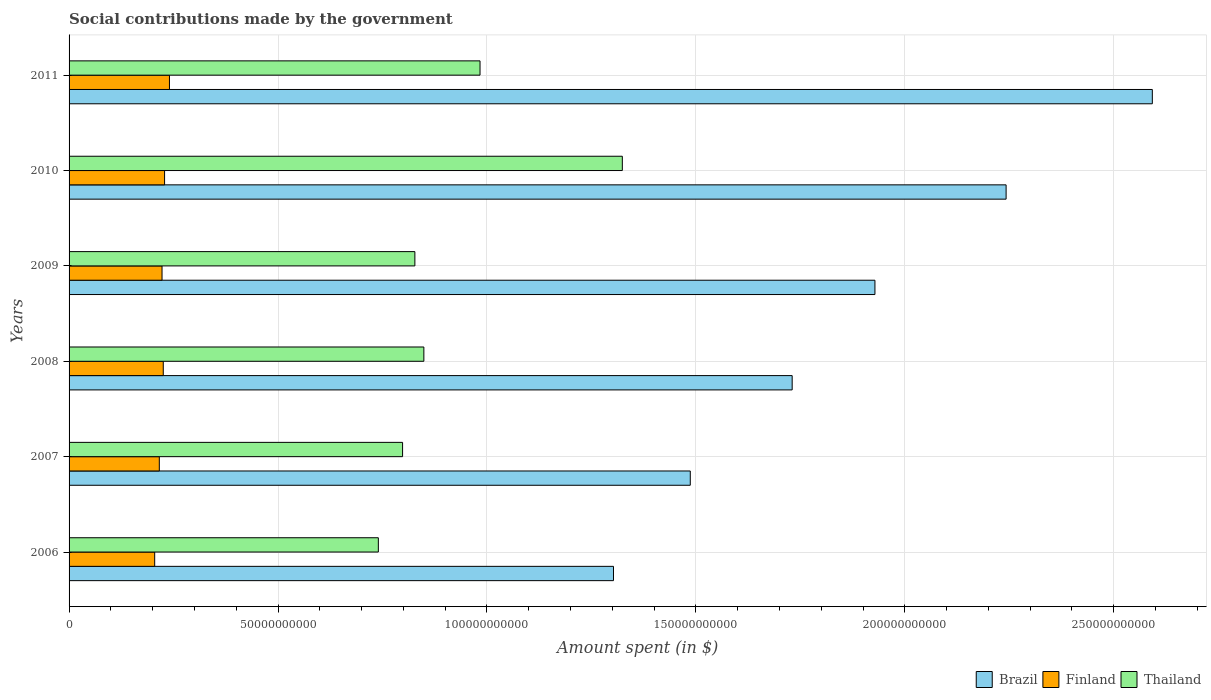How many different coloured bars are there?
Keep it short and to the point. 3. How many groups of bars are there?
Offer a very short reply. 6. Are the number of bars on each tick of the Y-axis equal?
Make the answer very short. Yes. How many bars are there on the 5th tick from the top?
Provide a short and direct response. 3. How many bars are there on the 3rd tick from the bottom?
Offer a very short reply. 3. What is the label of the 3rd group of bars from the top?
Your response must be concise. 2009. In how many cases, is the number of bars for a given year not equal to the number of legend labels?
Give a very brief answer. 0. What is the amount spent on social contributions in Finland in 2010?
Give a very brief answer. 2.29e+1. Across all years, what is the maximum amount spent on social contributions in Brazil?
Keep it short and to the point. 2.59e+11. Across all years, what is the minimum amount spent on social contributions in Brazil?
Your answer should be very brief. 1.30e+11. In which year was the amount spent on social contributions in Brazil minimum?
Your response must be concise. 2006. What is the total amount spent on social contributions in Brazil in the graph?
Give a very brief answer. 1.13e+12. What is the difference between the amount spent on social contributions in Thailand in 2008 and that in 2010?
Ensure brevity in your answer.  -4.75e+1. What is the difference between the amount spent on social contributions in Brazil in 2006 and the amount spent on social contributions in Finland in 2011?
Your answer should be compact. 1.06e+11. What is the average amount spent on social contributions in Brazil per year?
Offer a terse response. 1.88e+11. In the year 2011, what is the difference between the amount spent on social contributions in Finland and amount spent on social contributions in Brazil?
Your answer should be very brief. -2.35e+11. In how many years, is the amount spent on social contributions in Brazil greater than 40000000000 $?
Offer a terse response. 6. What is the ratio of the amount spent on social contributions in Finland in 2008 to that in 2011?
Provide a succinct answer. 0.94. Is the difference between the amount spent on social contributions in Finland in 2006 and 2007 greater than the difference between the amount spent on social contributions in Brazil in 2006 and 2007?
Make the answer very short. Yes. What is the difference between the highest and the second highest amount spent on social contributions in Thailand?
Ensure brevity in your answer.  3.41e+1. What is the difference between the highest and the lowest amount spent on social contributions in Brazil?
Ensure brevity in your answer.  1.29e+11. What does the 1st bar from the top in 2009 represents?
Offer a very short reply. Thailand. What does the 3rd bar from the bottom in 2006 represents?
Offer a terse response. Thailand. Is it the case that in every year, the sum of the amount spent on social contributions in Thailand and amount spent on social contributions in Finland is greater than the amount spent on social contributions in Brazil?
Offer a terse response. No. How many bars are there?
Your answer should be very brief. 18. Are all the bars in the graph horizontal?
Your answer should be compact. Yes. Where does the legend appear in the graph?
Give a very brief answer. Bottom right. How many legend labels are there?
Give a very brief answer. 3. How are the legend labels stacked?
Offer a very short reply. Horizontal. What is the title of the graph?
Provide a succinct answer. Social contributions made by the government. Does "Tanzania" appear as one of the legend labels in the graph?
Your answer should be compact. No. What is the label or title of the X-axis?
Keep it short and to the point. Amount spent (in $). What is the Amount spent (in $) of Brazil in 2006?
Your response must be concise. 1.30e+11. What is the Amount spent (in $) of Finland in 2006?
Provide a short and direct response. 2.05e+1. What is the Amount spent (in $) of Thailand in 2006?
Your response must be concise. 7.40e+1. What is the Amount spent (in $) in Brazil in 2007?
Provide a succinct answer. 1.49e+11. What is the Amount spent (in $) of Finland in 2007?
Offer a terse response. 2.16e+1. What is the Amount spent (in $) in Thailand in 2007?
Offer a terse response. 7.98e+1. What is the Amount spent (in $) in Brazil in 2008?
Make the answer very short. 1.73e+11. What is the Amount spent (in $) of Finland in 2008?
Offer a very short reply. 2.25e+1. What is the Amount spent (in $) of Thailand in 2008?
Provide a succinct answer. 8.49e+1. What is the Amount spent (in $) in Brazil in 2009?
Offer a very short reply. 1.93e+11. What is the Amount spent (in $) of Finland in 2009?
Your response must be concise. 2.22e+1. What is the Amount spent (in $) in Thailand in 2009?
Your answer should be compact. 8.28e+1. What is the Amount spent (in $) of Brazil in 2010?
Provide a short and direct response. 2.24e+11. What is the Amount spent (in $) of Finland in 2010?
Make the answer very short. 2.29e+1. What is the Amount spent (in $) of Thailand in 2010?
Keep it short and to the point. 1.32e+11. What is the Amount spent (in $) of Brazil in 2011?
Ensure brevity in your answer.  2.59e+11. What is the Amount spent (in $) in Finland in 2011?
Your response must be concise. 2.40e+1. What is the Amount spent (in $) in Thailand in 2011?
Ensure brevity in your answer.  9.83e+1. Across all years, what is the maximum Amount spent (in $) of Brazil?
Provide a succinct answer. 2.59e+11. Across all years, what is the maximum Amount spent (in $) of Finland?
Offer a very short reply. 2.40e+1. Across all years, what is the maximum Amount spent (in $) in Thailand?
Keep it short and to the point. 1.32e+11. Across all years, what is the minimum Amount spent (in $) in Brazil?
Offer a very short reply. 1.30e+11. Across all years, what is the minimum Amount spent (in $) of Finland?
Make the answer very short. 2.05e+1. Across all years, what is the minimum Amount spent (in $) of Thailand?
Your response must be concise. 7.40e+1. What is the total Amount spent (in $) in Brazil in the graph?
Keep it short and to the point. 1.13e+12. What is the total Amount spent (in $) of Finland in the graph?
Provide a short and direct response. 1.34e+11. What is the total Amount spent (in $) of Thailand in the graph?
Keep it short and to the point. 5.52e+11. What is the difference between the Amount spent (in $) in Brazil in 2006 and that in 2007?
Offer a very short reply. -1.84e+1. What is the difference between the Amount spent (in $) in Finland in 2006 and that in 2007?
Provide a succinct answer. -1.11e+09. What is the difference between the Amount spent (in $) of Thailand in 2006 and that in 2007?
Make the answer very short. -5.80e+09. What is the difference between the Amount spent (in $) in Brazil in 2006 and that in 2008?
Provide a succinct answer. -4.28e+1. What is the difference between the Amount spent (in $) in Finland in 2006 and that in 2008?
Keep it short and to the point. -2.05e+09. What is the difference between the Amount spent (in $) in Thailand in 2006 and that in 2008?
Offer a terse response. -1.09e+1. What is the difference between the Amount spent (in $) in Brazil in 2006 and that in 2009?
Offer a terse response. -6.26e+1. What is the difference between the Amount spent (in $) in Finland in 2006 and that in 2009?
Your response must be concise. -1.76e+09. What is the difference between the Amount spent (in $) in Thailand in 2006 and that in 2009?
Ensure brevity in your answer.  -8.74e+09. What is the difference between the Amount spent (in $) in Brazil in 2006 and that in 2010?
Keep it short and to the point. -9.40e+1. What is the difference between the Amount spent (in $) of Finland in 2006 and that in 2010?
Your answer should be very brief. -2.37e+09. What is the difference between the Amount spent (in $) of Thailand in 2006 and that in 2010?
Your response must be concise. -5.84e+1. What is the difference between the Amount spent (in $) of Brazil in 2006 and that in 2011?
Make the answer very short. -1.29e+11. What is the difference between the Amount spent (in $) of Finland in 2006 and that in 2011?
Offer a very short reply. -3.54e+09. What is the difference between the Amount spent (in $) in Thailand in 2006 and that in 2011?
Offer a terse response. -2.43e+1. What is the difference between the Amount spent (in $) in Brazil in 2007 and that in 2008?
Ensure brevity in your answer.  -2.44e+1. What is the difference between the Amount spent (in $) in Finland in 2007 and that in 2008?
Give a very brief answer. -9.45e+08. What is the difference between the Amount spent (in $) in Thailand in 2007 and that in 2008?
Ensure brevity in your answer.  -5.09e+09. What is the difference between the Amount spent (in $) of Brazil in 2007 and that in 2009?
Give a very brief answer. -4.42e+1. What is the difference between the Amount spent (in $) of Finland in 2007 and that in 2009?
Your answer should be compact. -6.51e+08. What is the difference between the Amount spent (in $) in Thailand in 2007 and that in 2009?
Make the answer very short. -2.94e+09. What is the difference between the Amount spent (in $) of Brazil in 2007 and that in 2010?
Give a very brief answer. -7.56e+1. What is the difference between the Amount spent (in $) in Finland in 2007 and that in 2010?
Provide a short and direct response. -1.26e+09. What is the difference between the Amount spent (in $) of Thailand in 2007 and that in 2010?
Provide a short and direct response. -5.26e+1. What is the difference between the Amount spent (in $) in Brazil in 2007 and that in 2011?
Your answer should be very brief. -1.11e+11. What is the difference between the Amount spent (in $) in Finland in 2007 and that in 2011?
Your response must be concise. -2.43e+09. What is the difference between the Amount spent (in $) of Thailand in 2007 and that in 2011?
Give a very brief answer. -1.85e+1. What is the difference between the Amount spent (in $) in Brazil in 2008 and that in 2009?
Keep it short and to the point. -1.98e+1. What is the difference between the Amount spent (in $) in Finland in 2008 and that in 2009?
Provide a short and direct response. 2.94e+08. What is the difference between the Amount spent (in $) in Thailand in 2008 and that in 2009?
Provide a short and direct response. 2.15e+09. What is the difference between the Amount spent (in $) of Brazil in 2008 and that in 2010?
Your response must be concise. -5.12e+1. What is the difference between the Amount spent (in $) of Finland in 2008 and that in 2010?
Your response must be concise. -3.15e+08. What is the difference between the Amount spent (in $) of Thailand in 2008 and that in 2010?
Ensure brevity in your answer.  -4.75e+1. What is the difference between the Amount spent (in $) of Brazil in 2008 and that in 2011?
Offer a very short reply. -8.62e+1. What is the difference between the Amount spent (in $) in Finland in 2008 and that in 2011?
Your answer should be very brief. -1.48e+09. What is the difference between the Amount spent (in $) of Thailand in 2008 and that in 2011?
Your answer should be very brief. -1.34e+1. What is the difference between the Amount spent (in $) in Brazil in 2009 and that in 2010?
Provide a short and direct response. -3.14e+1. What is the difference between the Amount spent (in $) of Finland in 2009 and that in 2010?
Provide a short and direct response. -6.09e+08. What is the difference between the Amount spent (in $) of Thailand in 2009 and that in 2010?
Give a very brief answer. -4.96e+1. What is the difference between the Amount spent (in $) in Brazil in 2009 and that in 2011?
Provide a short and direct response. -6.64e+1. What is the difference between the Amount spent (in $) of Finland in 2009 and that in 2011?
Offer a very short reply. -1.78e+09. What is the difference between the Amount spent (in $) of Thailand in 2009 and that in 2011?
Your answer should be compact. -1.56e+1. What is the difference between the Amount spent (in $) in Brazil in 2010 and that in 2011?
Offer a terse response. -3.50e+1. What is the difference between the Amount spent (in $) of Finland in 2010 and that in 2011?
Your response must be concise. -1.17e+09. What is the difference between the Amount spent (in $) of Thailand in 2010 and that in 2011?
Your answer should be very brief. 3.41e+1. What is the difference between the Amount spent (in $) of Brazil in 2006 and the Amount spent (in $) of Finland in 2007?
Your answer should be very brief. 1.09e+11. What is the difference between the Amount spent (in $) of Brazil in 2006 and the Amount spent (in $) of Thailand in 2007?
Make the answer very short. 5.05e+1. What is the difference between the Amount spent (in $) of Finland in 2006 and the Amount spent (in $) of Thailand in 2007?
Give a very brief answer. -5.93e+1. What is the difference between the Amount spent (in $) of Brazil in 2006 and the Amount spent (in $) of Finland in 2008?
Ensure brevity in your answer.  1.08e+11. What is the difference between the Amount spent (in $) in Brazil in 2006 and the Amount spent (in $) in Thailand in 2008?
Make the answer very short. 4.54e+1. What is the difference between the Amount spent (in $) in Finland in 2006 and the Amount spent (in $) in Thailand in 2008?
Your answer should be very brief. -6.44e+1. What is the difference between the Amount spent (in $) in Brazil in 2006 and the Amount spent (in $) in Finland in 2009?
Provide a short and direct response. 1.08e+11. What is the difference between the Amount spent (in $) of Brazil in 2006 and the Amount spent (in $) of Thailand in 2009?
Ensure brevity in your answer.  4.75e+1. What is the difference between the Amount spent (in $) in Finland in 2006 and the Amount spent (in $) in Thailand in 2009?
Provide a short and direct response. -6.23e+1. What is the difference between the Amount spent (in $) of Brazil in 2006 and the Amount spent (in $) of Finland in 2010?
Give a very brief answer. 1.07e+11. What is the difference between the Amount spent (in $) in Brazil in 2006 and the Amount spent (in $) in Thailand in 2010?
Make the answer very short. -2.12e+09. What is the difference between the Amount spent (in $) in Finland in 2006 and the Amount spent (in $) in Thailand in 2010?
Your answer should be very brief. -1.12e+11. What is the difference between the Amount spent (in $) of Brazil in 2006 and the Amount spent (in $) of Finland in 2011?
Your answer should be very brief. 1.06e+11. What is the difference between the Amount spent (in $) of Brazil in 2006 and the Amount spent (in $) of Thailand in 2011?
Your answer should be compact. 3.19e+1. What is the difference between the Amount spent (in $) in Finland in 2006 and the Amount spent (in $) in Thailand in 2011?
Give a very brief answer. -7.79e+1. What is the difference between the Amount spent (in $) of Brazil in 2007 and the Amount spent (in $) of Finland in 2008?
Offer a very short reply. 1.26e+11. What is the difference between the Amount spent (in $) of Brazil in 2007 and the Amount spent (in $) of Thailand in 2008?
Your response must be concise. 6.38e+1. What is the difference between the Amount spent (in $) of Finland in 2007 and the Amount spent (in $) of Thailand in 2008?
Your answer should be very brief. -6.33e+1. What is the difference between the Amount spent (in $) in Brazil in 2007 and the Amount spent (in $) in Finland in 2009?
Provide a short and direct response. 1.26e+11. What is the difference between the Amount spent (in $) of Brazil in 2007 and the Amount spent (in $) of Thailand in 2009?
Your answer should be very brief. 6.59e+1. What is the difference between the Amount spent (in $) of Finland in 2007 and the Amount spent (in $) of Thailand in 2009?
Your answer should be compact. -6.12e+1. What is the difference between the Amount spent (in $) in Brazil in 2007 and the Amount spent (in $) in Finland in 2010?
Offer a terse response. 1.26e+11. What is the difference between the Amount spent (in $) of Brazil in 2007 and the Amount spent (in $) of Thailand in 2010?
Your answer should be compact. 1.63e+1. What is the difference between the Amount spent (in $) of Finland in 2007 and the Amount spent (in $) of Thailand in 2010?
Provide a succinct answer. -1.11e+11. What is the difference between the Amount spent (in $) in Brazil in 2007 and the Amount spent (in $) in Finland in 2011?
Make the answer very short. 1.25e+11. What is the difference between the Amount spent (in $) of Brazil in 2007 and the Amount spent (in $) of Thailand in 2011?
Give a very brief answer. 5.03e+1. What is the difference between the Amount spent (in $) of Finland in 2007 and the Amount spent (in $) of Thailand in 2011?
Offer a terse response. -7.67e+1. What is the difference between the Amount spent (in $) of Brazil in 2008 and the Amount spent (in $) of Finland in 2009?
Your answer should be compact. 1.51e+11. What is the difference between the Amount spent (in $) of Brazil in 2008 and the Amount spent (in $) of Thailand in 2009?
Provide a short and direct response. 9.03e+1. What is the difference between the Amount spent (in $) of Finland in 2008 and the Amount spent (in $) of Thailand in 2009?
Ensure brevity in your answer.  -6.02e+1. What is the difference between the Amount spent (in $) of Brazil in 2008 and the Amount spent (in $) of Finland in 2010?
Offer a terse response. 1.50e+11. What is the difference between the Amount spent (in $) of Brazil in 2008 and the Amount spent (in $) of Thailand in 2010?
Offer a terse response. 4.06e+1. What is the difference between the Amount spent (in $) of Finland in 2008 and the Amount spent (in $) of Thailand in 2010?
Make the answer very short. -1.10e+11. What is the difference between the Amount spent (in $) of Brazil in 2008 and the Amount spent (in $) of Finland in 2011?
Provide a succinct answer. 1.49e+11. What is the difference between the Amount spent (in $) of Brazil in 2008 and the Amount spent (in $) of Thailand in 2011?
Offer a terse response. 7.47e+1. What is the difference between the Amount spent (in $) of Finland in 2008 and the Amount spent (in $) of Thailand in 2011?
Your response must be concise. -7.58e+1. What is the difference between the Amount spent (in $) in Brazil in 2009 and the Amount spent (in $) in Finland in 2010?
Your response must be concise. 1.70e+11. What is the difference between the Amount spent (in $) of Brazil in 2009 and the Amount spent (in $) of Thailand in 2010?
Your answer should be compact. 6.05e+1. What is the difference between the Amount spent (in $) of Finland in 2009 and the Amount spent (in $) of Thailand in 2010?
Your answer should be compact. -1.10e+11. What is the difference between the Amount spent (in $) in Brazil in 2009 and the Amount spent (in $) in Finland in 2011?
Your response must be concise. 1.69e+11. What is the difference between the Amount spent (in $) in Brazil in 2009 and the Amount spent (in $) in Thailand in 2011?
Offer a very short reply. 9.45e+1. What is the difference between the Amount spent (in $) in Finland in 2009 and the Amount spent (in $) in Thailand in 2011?
Offer a terse response. -7.61e+1. What is the difference between the Amount spent (in $) of Brazil in 2010 and the Amount spent (in $) of Finland in 2011?
Offer a very short reply. 2.00e+11. What is the difference between the Amount spent (in $) of Brazil in 2010 and the Amount spent (in $) of Thailand in 2011?
Give a very brief answer. 1.26e+11. What is the difference between the Amount spent (in $) in Finland in 2010 and the Amount spent (in $) in Thailand in 2011?
Your answer should be compact. -7.55e+1. What is the average Amount spent (in $) of Brazil per year?
Provide a short and direct response. 1.88e+11. What is the average Amount spent (in $) in Finland per year?
Keep it short and to the point. 2.23e+1. What is the average Amount spent (in $) of Thailand per year?
Your answer should be compact. 9.20e+1. In the year 2006, what is the difference between the Amount spent (in $) of Brazil and Amount spent (in $) of Finland?
Your response must be concise. 1.10e+11. In the year 2006, what is the difference between the Amount spent (in $) in Brazil and Amount spent (in $) in Thailand?
Provide a short and direct response. 5.63e+1. In the year 2006, what is the difference between the Amount spent (in $) in Finland and Amount spent (in $) in Thailand?
Provide a short and direct response. -5.35e+1. In the year 2007, what is the difference between the Amount spent (in $) in Brazil and Amount spent (in $) in Finland?
Give a very brief answer. 1.27e+11. In the year 2007, what is the difference between the Amount spent (in $) in Brazil and Amount spent (in $) in Thailand?
Make the answer very short. 6.88e+1. In the year 2007, what is the difference between the Amount spent (in $) in Finland and Amount spent (in $) in Thailand?
Your answer should be very brief. -5.82e+1. In the year 2008, what is the difference between the Amount spent (in $) in Brazil and Amount spent (in $) in Finland?
Offer a terse response. 1.51e+11. In the year 2008, what is the difference between the Amount spent (in $) of Brazil and Amount spent (in $) of Thailand?
Give a very brief answer. 8.81e+1. In the year 2008, what is the difference between the Amount spent (in $) of Finland and Amount spent (in $) of Thailand?
Offer a very short reply. -6.24e+1. In the year 2009, what is the difference between the Amount spent (in $) of Brazil and Amount spent (in $) of Finland?
Ensure brevity in your answer.  1.71e+11. In the year 2009, what is the difference between the Amount spent (in $) in Brazil and Amount spent (in $) in Thailand?
Keep it short and to the point. 1.10e+11. In the year 2009, what is the difference between the Amount spent (in $) of Finland and Amount spent (in $) of Thailand?
Keep it short and to the point. -6.05e+1. In the year 2010, what is the difference between the Amount spent (in $) in Brazil and Amount spent (in $) in Finland?
Offer a very short reply. 2.01e+11. In the year 2010, what is the difference between the Amount spent (in $) in Brazil and Amount spent (in $) in Thailand?
Provide a succinct answer. 9.18e+1. In the year 2010, what is the difference between the Amount spent (in $) of Finland and Amount spent (in $) of Thailand?
Keep it short and to the point. -1.10e+11. In the year 2011, what is the difference between the Amount spent (in $) in Brazil and Amount spent (in $) in Finland?
Give a very brief answer. 2.35e+11. In the year 2011, what is the difference between the Amount spent (in $) of Brazil and Amount spent (in $) of Thailand?
Your answer should be very brief. 1.61e+11. In the year 2011, what is the difference between the Amount spent (in $) in Finland and Amount spent (in $) in Thailand?
Your response must be concise. -7.43e+1. What is the ratio of the Amount spent (in $) in Brazil in 2006 to that in 2007?
Give a very brief answer. 0.88. What is the ratio of the Amount spent (in $) in Finland in 2006 to that in 2007?
Make the answer very short. 0.95. What is the ratio of the Amount spent (in $) in Thailand in 2006 to that in 2007?
Give a very brief answer. 0.93. What is the ratio of the Amount spent (in $) of Brazil in 2006 to that in 2008?
Ensure brevity in your answer.  0.75. What is the ratio of the Amount spent (in $) in Finland in 2006 to that in 2008?
Your answer should be very brief. 0.91. What is the ratio of the Amount spent (in $) of Thailand in 2006 to that in 2008?
Your answer should be very brief. 0.87. What is the ratio of the Amount spent (in $) of Brazil in 2006 to that in 2009?
Provide a succinct answer. 0.68. What is the ratio of the Amount spent (in $) in Finland in 2006 to that in 2009?
Give a very brief answer. 0.92. What is the ratio of the Amount spent (in $) of Thailand in 2006 to that in 2009?
Offer a terse response. 0.89. What is the ratio of the Amount spent (in $) in Brazil in 2006 to that in 2010?
Make the answer very short. 0.58. What is the ratio of the Amount spent (in $) of Finland in 2006 to that in 2010?
Make the answer very short. 0.9. What is the ratio of the Amount spent (in $) in Thailand in 2006 to that in 2010?
Keep it short and to the point. 0.56. What is the ratio of the Amount spent (in $) of Brazil in 2006 to that in 2011?
Give a very brief answer. 0.5. What is the ratio of the Amount spent (in $) in Finland in 2006 to that in 2011?
Your answer should be compact. 0.85. What is the ratio of the Amount spent (in $) in Thailand in 2006 to that in 2011?
Give a very brief answer. 0.75. What is the ratio of the Amount spent (in $) of Brazil in 2007 to that in 2008?
Your answer should be compact. 0.86. What is the ratio of the Amount spent (in $) in Finland in 2007 to that in 2008?
Ensure brevity in your answer.  0.96. What is the ratio of the Amount spent (in $) of Thailand in 2007 to that in 2008?
Your answer should be compact. 0.94. What is the ratio of the Amount spent (in $) of Brazil in 2007 to that in 2009?
Ensure brevity in your answer.  0.77. What is the ratio of the Amount spent (in $) in Finland in 2007 to that in 2009?
Give a very brief answer. 0.97. What is the ratio of the Amount spent (in $) of Thailand in 2007 to that in 2009?
Keep it short and to the point. 0.96. What is the ratio of the Amount spent (in $) of Brazil in 2007 to that in 2010?
Offer a very short reply. 0.66. What is the ratio of the Amount spent (in $) in Finland in 2007 to that in 2010?
Provide a succinct answer. 0.94. What is the ratio of the Amount spent (in $) in Thailand in 2007 to that in 2010?
Offer a terse response. 0.6. What is the ratio of the Amount spent (in $) of Brazil in 2007 to that in 2011?
Provide a succinct answer. 0.57. What is the ratio of the Amount spent (in $) of Finland in 2007 to that in 2011?
Offer a very short reply. 0.9. What is the ratio of the Amount spent (in $) in Thailand in 2007 to that in 2011?
Make the answer very short. 0.81. What is the ratio of the Amount spent (in $) in Brazil in 2008 to that in 2009?
Give a very brief answer. 0.9. What is the ratio of the Amount spent (in $) in Finland in 2008 to that in 2009?
Give a very brief answer. 1.01. What is the ratio of the Amount spent (in $) in Thailand in 2008 to that in 2009?
Ensure brevity in your answer.  1.03. What is the ratio of the Amount spent (in $) in Brazil in 2008 to that in 2010?
Your response must be concise. 0.77. What is the ratio of the Amount spent (in $) of Finland in 2008 to that in 2010?
Make the answer very short. 0.99. What is the ratio of the Amount spent (in $) in Thailand in 2008 to that in 2010?
Give a very brief answer. 0.64. What is the ratio of the Amount spent (in $) of Brazil in 2008 to that in 2011?
Offer a very short reply. 0.67. What is the ratio of the Amount spent (in $) in Finland in 2008 to that in 2011?
Your answer should be very brief. 0.94. What is the ratio of the Amount spent (in $) in Thailand in 2008 to that in 2011?
Provide a short and direct response. 0.86. What is the ratio of the Amount spent (in $) of Brazil in 2009 to that in 2010?
Keep it short and to the point. 0.86. What is the ratio of the Amount spent (in $) of Finland in 2009 to that in 2010?
Ensure brevity in your answer.  0.97. What is the ratio of the Amount spent (in $) of Brazil in 2009 to that in 2011?
Provide a short and direct response. 0.74. What is the ratio of the Amount spent (in $) of Finland in 2009 to that in 2011?
Offer a terse response. 0.93. What is the ratio of the Amount spent (in $) of Thailand in 2009 to that in 2011?
Keep it short and to the point. 0.84. What is the ratio of the Amount spent (in $) in Brazil in 2010 to that in 2011?
Offer a terse response. 0.86. What is the ratio of the Amount spent (in $) of Finland in 2010 to that in 2011?
Keep it short and to the point. 0.95. What is the ratio of the Amount spent (in $) in Thailand in 2010 to that in 2011?
Make the answer very short. 1.35. What is the difference between the highest and the second highest Amount spent (in $) of Brazil?
Provide a succinct answer. 3.50e+1. What is the difference between the highest and the second highest Amount spent (in $) of Finland?
Provide a short and direct response. 1.17e+09. What is the difference between the highest and the second highest Amount spent (in $) in Thailand?
Keep it short and to the point. 3.41e+1. What is the difference between the highest and the lowest Amount spent (in $) in Brazil?
Provide a short and direct response. 1.29e+11. What is the difference between the highest and the lowest Amount spent (in $) of Finland?
Your response must be concise. 3.54e+09. What is the difference between the highest and the lowest Amount spent (in $) in Thailand?
Keep it short and to the point. 5.84e+1. 